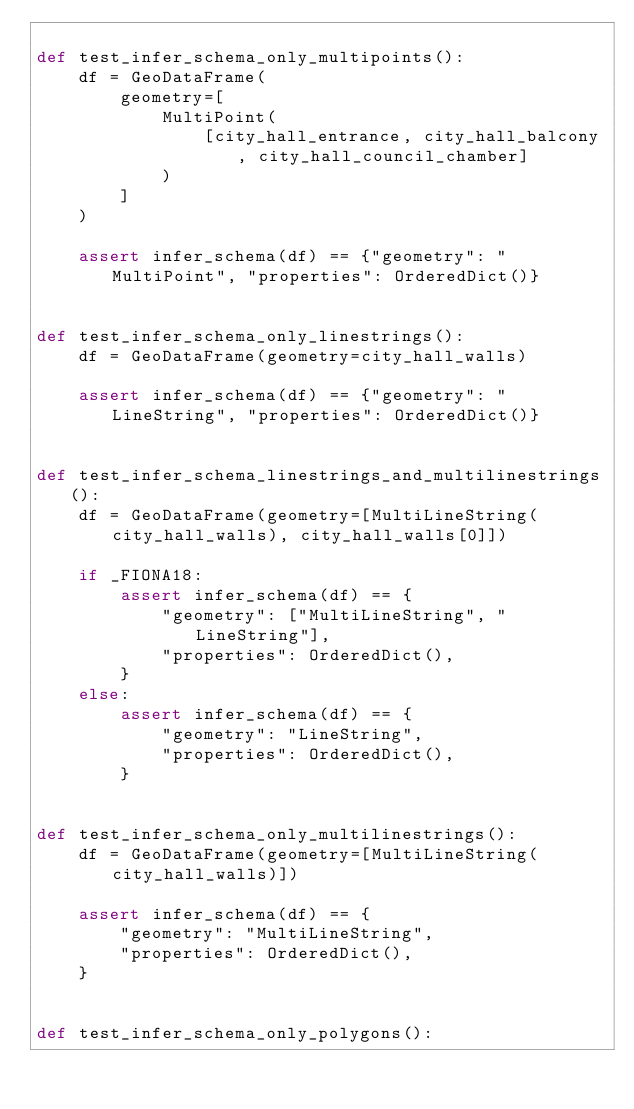Convert code to text. <code><loc_0><loc_0><loc_500><loc_500><_Python_>
def test_infer_schema_only_multipoints():
    df = GeoDataFrame(
        geometry=[
            MultiPoint(
                [city_hall_entrance, city_hall_balcony, city_hall_council_chamber]
            )
        ]
    )

    assert infer_schema(df) == {"geometry": "MultiPoint", "properties": OrderedDict()}


def test_infer_schema_only_linestrings():
    df = GeoDataFrame(geometry=city_hall_walls)

    assert infer_schema(df) == {"geometry": "LineString", "properties": OrderedDict()}


def test_infer_schema_linestrings_and_multilinestrings():
    df = GeoDataFrame(geometry=[MultiLineString(city_hall_walls), city_hall_walls[0]])

    if _FIONA18:
        assert infer_schema(df) == {
            "geometry": ["MultiLineString", "LineString"],
            "properties": OrderedDict(),
        }
    else:
        assert infer_schema(df) == {
            "geometry": "LineString",
            "properties": OrderedDict(),
        }


def test_infer_schema_only_multilinestrings():
    df = GeoDataFrame(geometry=[MultiLineString(city_hall_walls)])

    assert infer_schema(df) == {
        "geometry": "MultiLineString",
        "properties": OrderedDict(),
    }


def test_infer_schema_only_polygons():</code> 